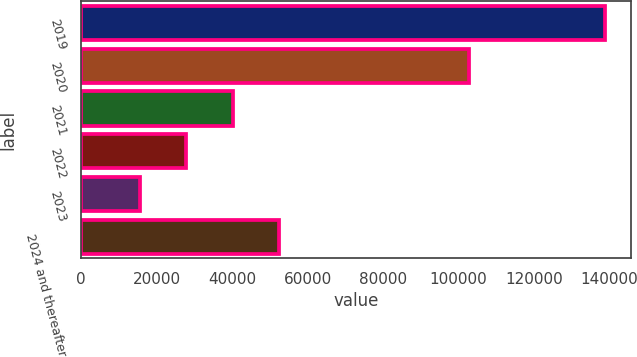Convert chart to OTSL. <chart><loc_0><loc_0><loc_500><loc_500><bar_chart><fcel>2019<fcel>2020<fcel>2021<fcel>2022<fcel>2023<fcel>2024 and thereafter<nl><fcel>138851<fcel>102773<fcel>40159<fcel>27822.5<fcel>15486<fcel>52495.5<nl></chart> 